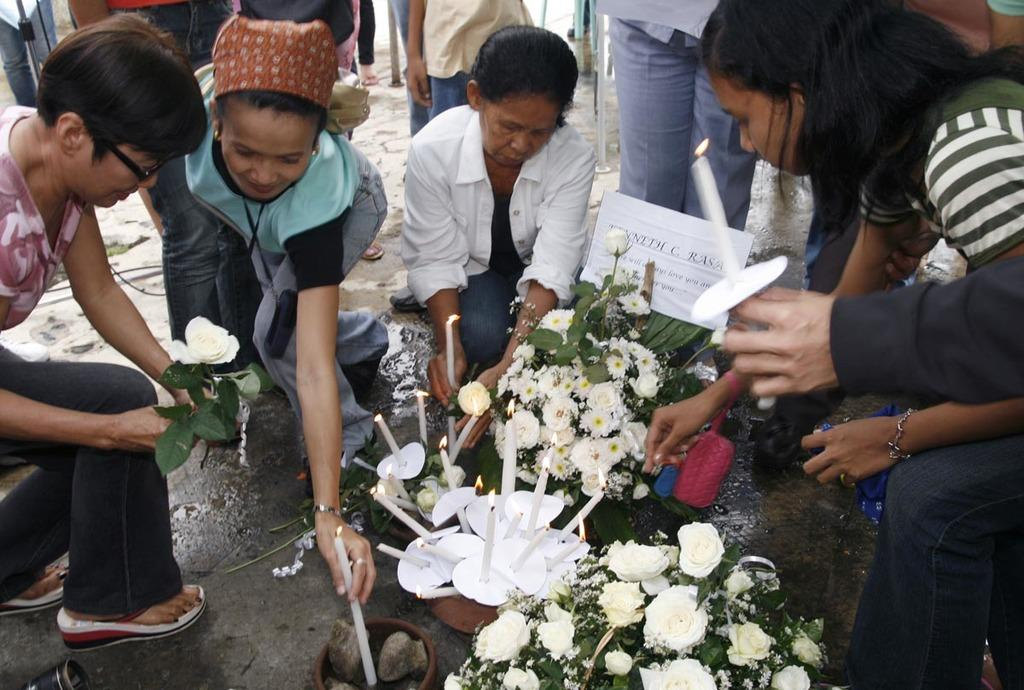What type of plants can be seen in the image? There are flowers in the image. What object is present on the ground in the image? There is a candle on the ground in the image. What are the women in the image doing? The women are holding candles and lighting them. How many candles are visible in the image? There is one candle on the ground and multiple candles being held by the women, so there are at least two candles visible. Is there a volcano erupting in the background of the image? No, there is no volcano present in the image. What type of yarn is being used by the women to light the candles? There is no yarn present in the image; the women are using candles to light the candles. 